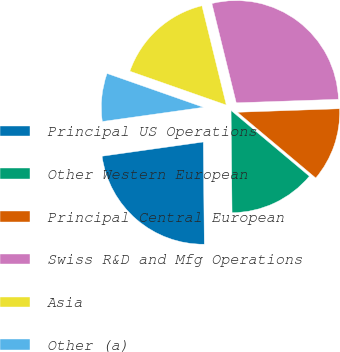Convert chart to OTSL. <chart><loc_0><loc_0><loc_500><loc_500><pie_chart><fcel>Principal US Operations<fcel>Other Western European<fcel>Principal Central European<fcel>Swiss R&D and Mfg Operations<fcel>Asia<fcel>Other (a)<nl><fcel>22.93%<fcel>13.73%<fcel>11.66%<fcel>28.28%<fcel>15.8%<fcel>7.59%<nl></chart> 